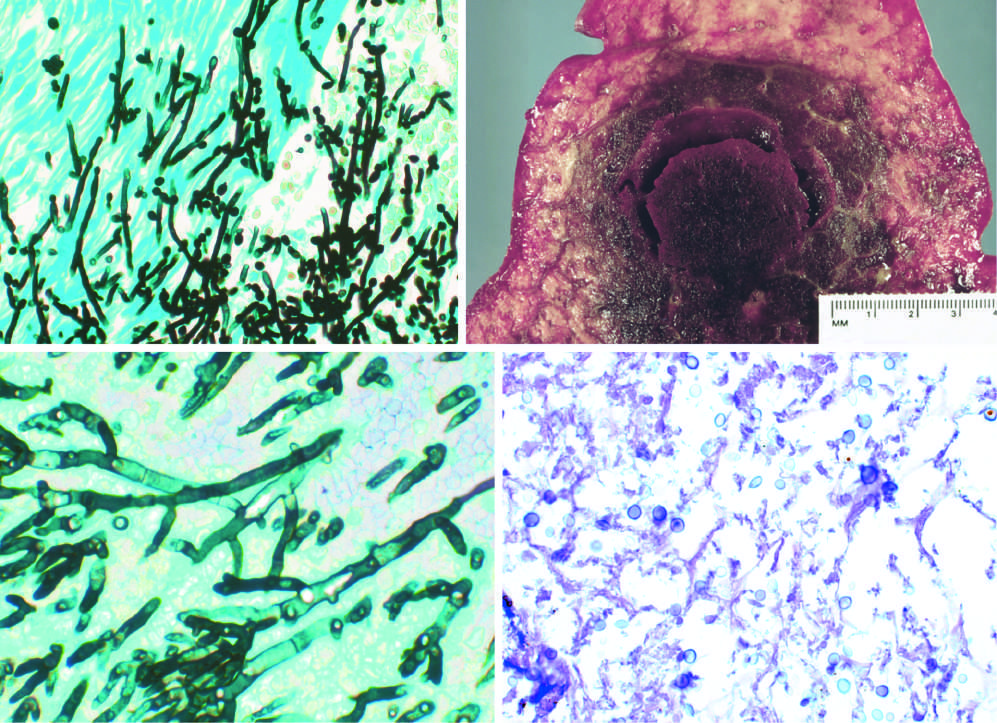what are somewhat variable in size?
Answer the question using a single word or phrase. The organisms 